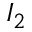Convert formula to latex. <formula><loc_0><loc_0><loc_500><loc_500>I _ { 2 }</formula> 